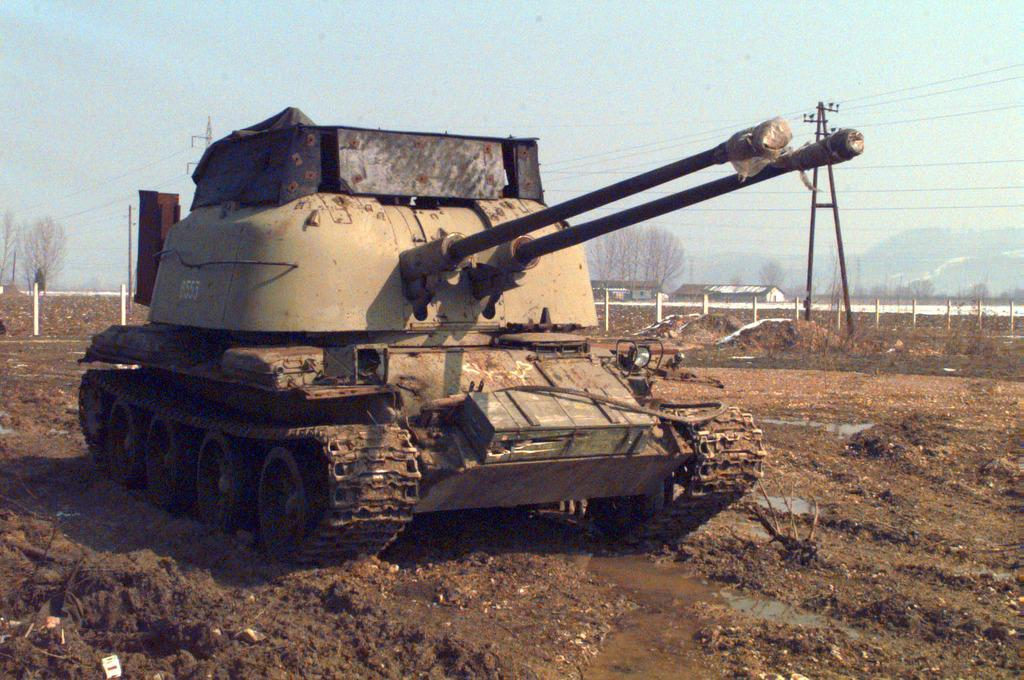What is the main subject on the ground in the image? There is a vehicle on the ground in the image. What can be seen in the background of the image? There are houses, trees, poles, and the sky visible in the background of the image. What year is the joke being told in the image? There is no joke being told in the image, so it is not possible to determine the year. 